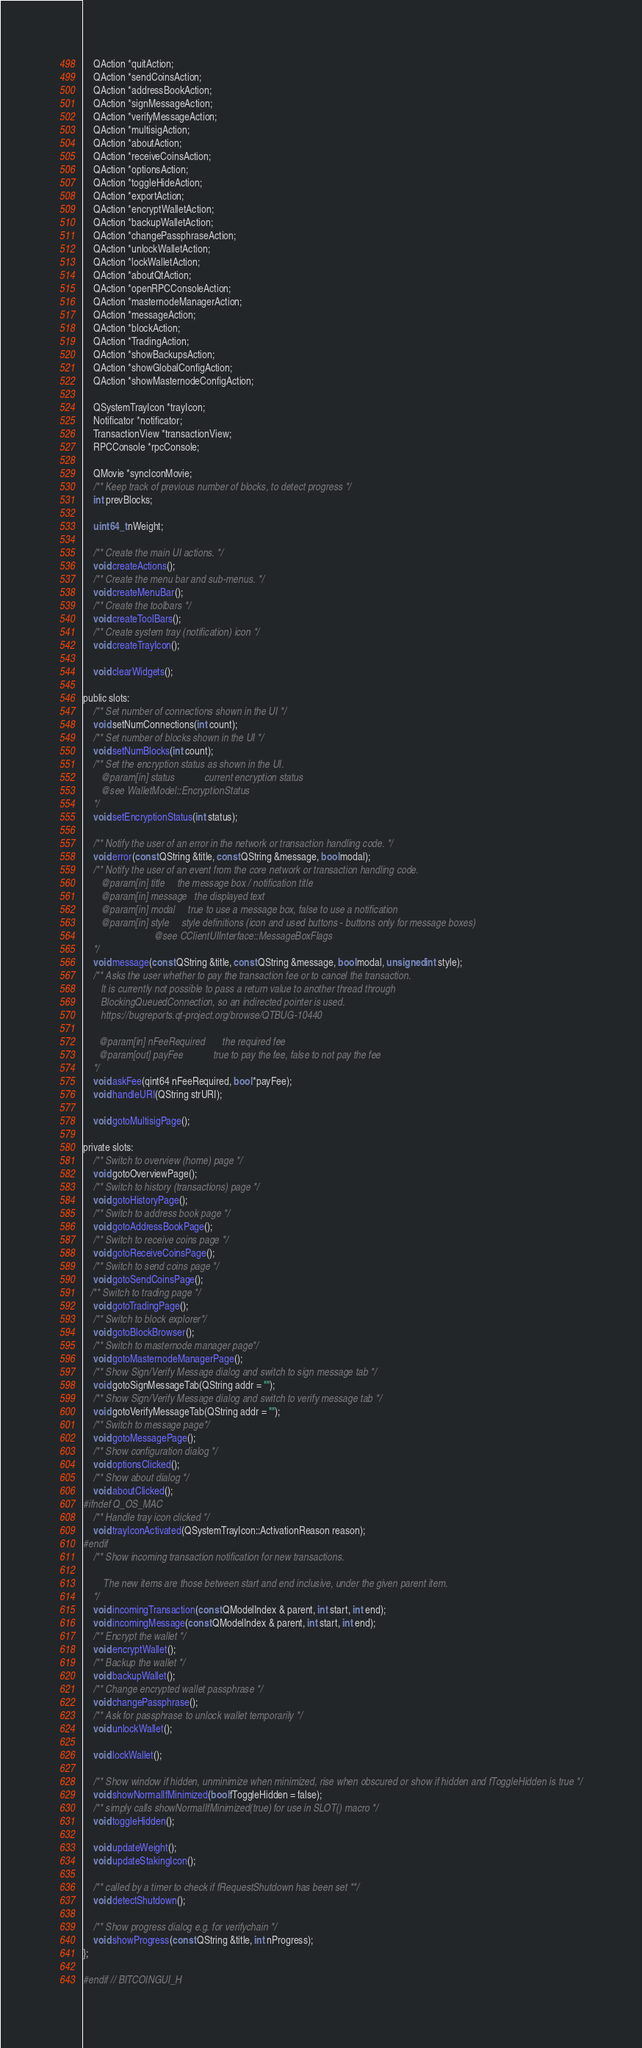<code> <loc_0><loc_0><loc_500><loc_500><_C_>    QAction *quitAction;
    QAction *sendCoinsAction;
    QAction *addressBookAction;
    QAction *signMessageAction;
    QAction *verifyMessageAction;
    QAction *multisigAction;
    QAction *aboutAction;
    QAction *receiveCoinsAction;
    QAction *optionsAction;
    QAction *toggleHideAction;
    QAction *exportAction;
    QAction *encryptWalletAction;
    QAction *backupWalletAction;
    QAction *changePassphraseAction;
    QAction *unlockWalletAction;
    QAction *lockWalletAction;
    QAction *aboutQtAction;
    QAction *openRPCConsoleAction;
    QAction *masternodeManagerAction;
    QAction *messageAction;
    QAction *blockAction;
    QAction *TradingAction;
    QAction *showBackupsAction;
    QAction *showGlobalConfigAction;
    QAction *showMasternodeConfigAction;

    QSystemTrayIcon *trayIcon;
    Notificator *notificator;
    TransactionView *transactionView;
    RPCConsole *rpcConsole;

    QMovie *syncIconMovie;
    /** Keep track of previous number of blocks, to detect progress */
    int prevBlocks;

    uint64_t nWeight;

    /** Create the main UI actions. */
    void createActions();
    /** Create the menu bar and sub-menus. */
    void createMenuBar();
    /** Create the toolbars */
    void createToolBars();
    /** Create system tray (notification) icon */
    void createTrayIcon();

    void clearWidgets();

public slots:
    /** Set number of connections shown in the UI */
    void setNumConnections(int count);
    /** Set number of blocks shown in the UI */
    void setNumBlocks(int count);
    /** Set the encryption status as shown in the UI.
       @param[in] status            current encryption status
       @see WalletModel::EncryptionStatus
    */
    void setEncryptionStatus(int status);

    /** Notify the user of an error in the network or transaction handling code. */
    void error(const QString &title, const QString &message, bool modal);
    /** Notify the user of an event from the core network or transaction handling code.
       @param[in] title     the message box / notification title
       @param[in] message   the displayed text
       @param[in] modal     true to use a message box, false to use a notification
       @param[in] style     style definitions (icon and used buttons - buttons only for message boxes)
                            @see CClientUIInterface::MessageBoxFlags
    */
    void message(const QString &title, const QString &message, bool modal, unsigned int style);
    /** Asks the user whether to pay the transaction fee or to cancel the transaction.
       It is currently not possible to pass a return value to another thread through
       BlockingQueuedConnection, so an indirected pointer is used.
       https://bugreports.qt-project.org/browse/QTBUG-10440

      @param[in] nFeeRequired       the required fee
      @param[out] payFee            true to pay the fee, false to not pay the fee
    */
    void askFee(qint64 nFeeRequired, bool *payFee);
    void handleURI(QString strURI);

    void gotoMultisigPage();

private slots:
    /** Switch to overview (home) page */
    void gotoOverviewPage();
    /** Switch to history (transactions) page */
    void gotoHistoryPage();
    /** Switch to address book page */
    void gotoAddressBookPage();
    /** Switch to receive coins page */
    void gotoReceiveCoinsPage();
    /** Switch to send coins page */
    void gotoSendCoinsPage();
   /** Switch to trading page */
    void gotoTradingPage();
    /** Switch to block explorer*/
    void gotoBlockBrowser();
    /** Switch to masternode manager page*/
    void gotoMasternodeManagerPage();
    /** Show Sign/Verify Message dialog and switch to sign message tab */
    void gotoSignMessageTab(QString addr = "");
    /** Show Sign/Verify Message dialog and switch to verify message tab */
    void gotoVerifyMessageTab(QString addr = "");
    /** Switch to message page*/
    void gotoMessagePage();
    /** Show configuration dialog */
    void optionsClicked();
    /** Show about dialog */
    void aboutClicked();
#ifndef Q_OS_MAC
    /** Handle tray icon clicked */
    void trayIconActivated(QSystemTrayIcon::ActivationReason reason);
#endif
    /** Show incoming transaction notification for new transactions.

        The new items are those between start and end inclusive, under the given parent item.
    */
    void incomingTransaction(const QModelIndex & parent, int start, int end);
    void incomingMessage(const QModelIndex & parent, int start, int end);
    /** Encrypt the wallet */
    void encryptWallet();
    /** Backup the wallet */
    void backupWallet();
    /** Change encrypted wallet passphrase */
    void changePassphrase();
    /** Ask for passphrase to unlock wallet temporarily */
    void unlockWallet();

    void lockWallet();

    /** Show window if hidden, unminimize when minimized, rise when obscured or show if hidden and fToggleHidden is true */
    void showNormalIfMinimized(bool fToggleHidden = false);
    /** simply calls showNormalIfMinimized(true) for use in SLOT() macro */
    void toggleHidden();

    void updateWeight();
    void updateStakingIcon();

    /** called by a timer to check if fRequestShutdown has been set **/
    void detectShutdown();

    /** Show progress dialog e.g. for verifychain */
    void showProgress(const QString &title, int nProgress);
};

#endif // BITCOINGUI_H
</code> 